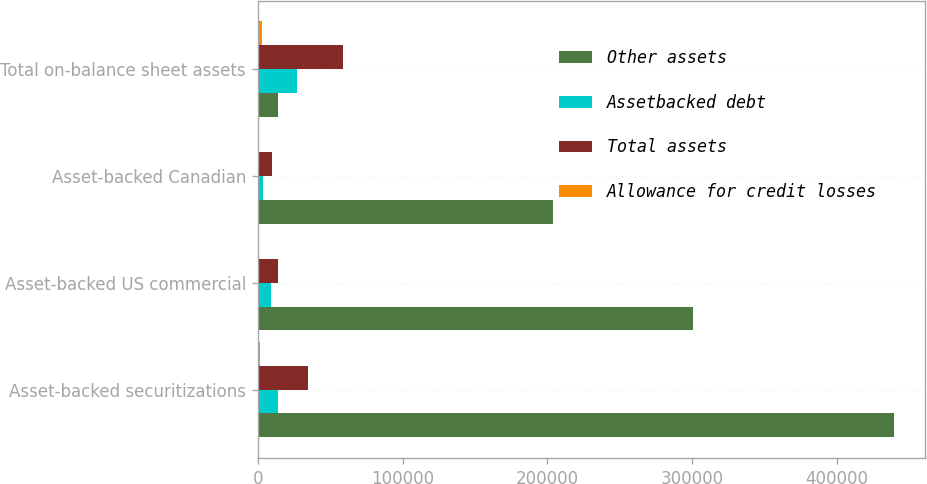Convert chart to OTSL. <chart><loc_0><loc_0><loc_500><loc_500><stacked_bar_chart><ecel><fcel>Asset-backed securitizations<fcel>Asset-backed US commercial<fcel>Asset-backed Canadian<fcel>Total on-balance sheet assets<nl><fcel>Other assets<fcel>439301<fcel>300530<fcel>203691<fcel>13686<nl><fcel>Assetbacked debt<fcel>13686<fcel>9392<fcel>3746<fcel>26824<nl><fcel>Total assets<fcel>34919<fcel>13787<fcel>9983<fcel>58689<nl><fcel>Allowance for credit losses<fcel>1260<fcel>888<fcel>470<fcel>2618<nl></chart> 